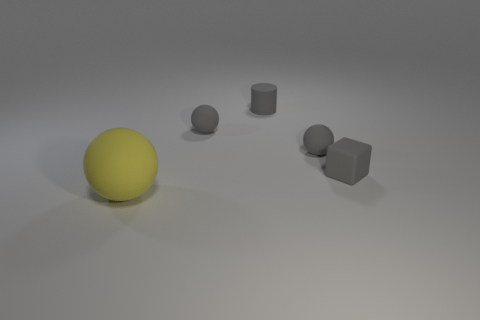Add 1 big yellow matte balls. How many objects exist? 6 Subtract all balls. How many objects are left? 2 Subtract all gray spheres. Subtract all large rubber balls. How many objects are left? 2 Add 3 gray rubber spheres. How many gray rubber spheres are left? 5 Add 5 large matte objects. How many large matte objects exist? 6 Subtract 2 gray balls. How many objects are left? 3 